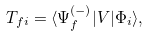<formula> <loc_0><loc_0><loc_500><loc_500>T _ { f i } = \langle \Psi _ { f } ^ { ( - ) } | V | \Phi _ { i } \rangle ,</formula> 